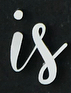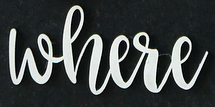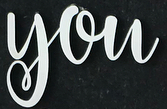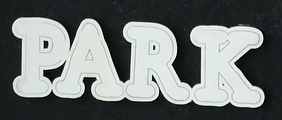What words are shown in these images in order, separated by a semicolon? is; where; you; PARK 